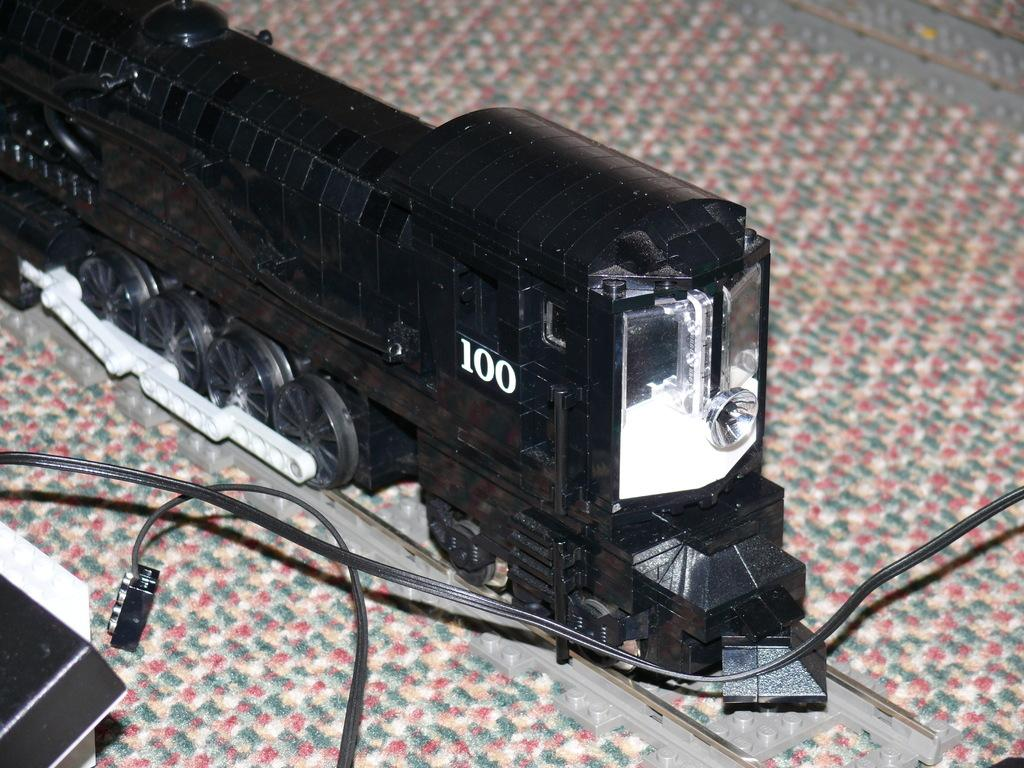What type of toy is in the image? There is a toy train in the image. What color is the toy train? The toy train is black in color. What is located at the bottom of the image? There is a box at the bottom of the image. What else can be seen at the bottom of the image? There are wires visible at the bottom of the image. How does the secretary contribute to the division of labor in the image? There is no secretary present in the image, so it is not possible to discuss their contribution to the division of labor. 